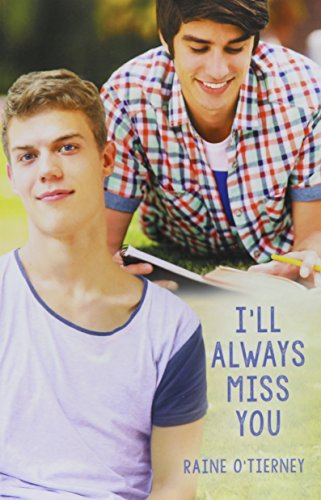Is this book related to Literature & Fiction? No, this book is not categorized under 'Literature & Fiction' but rather fits more distinctly within the 'Teen & Young Adult' genre. 